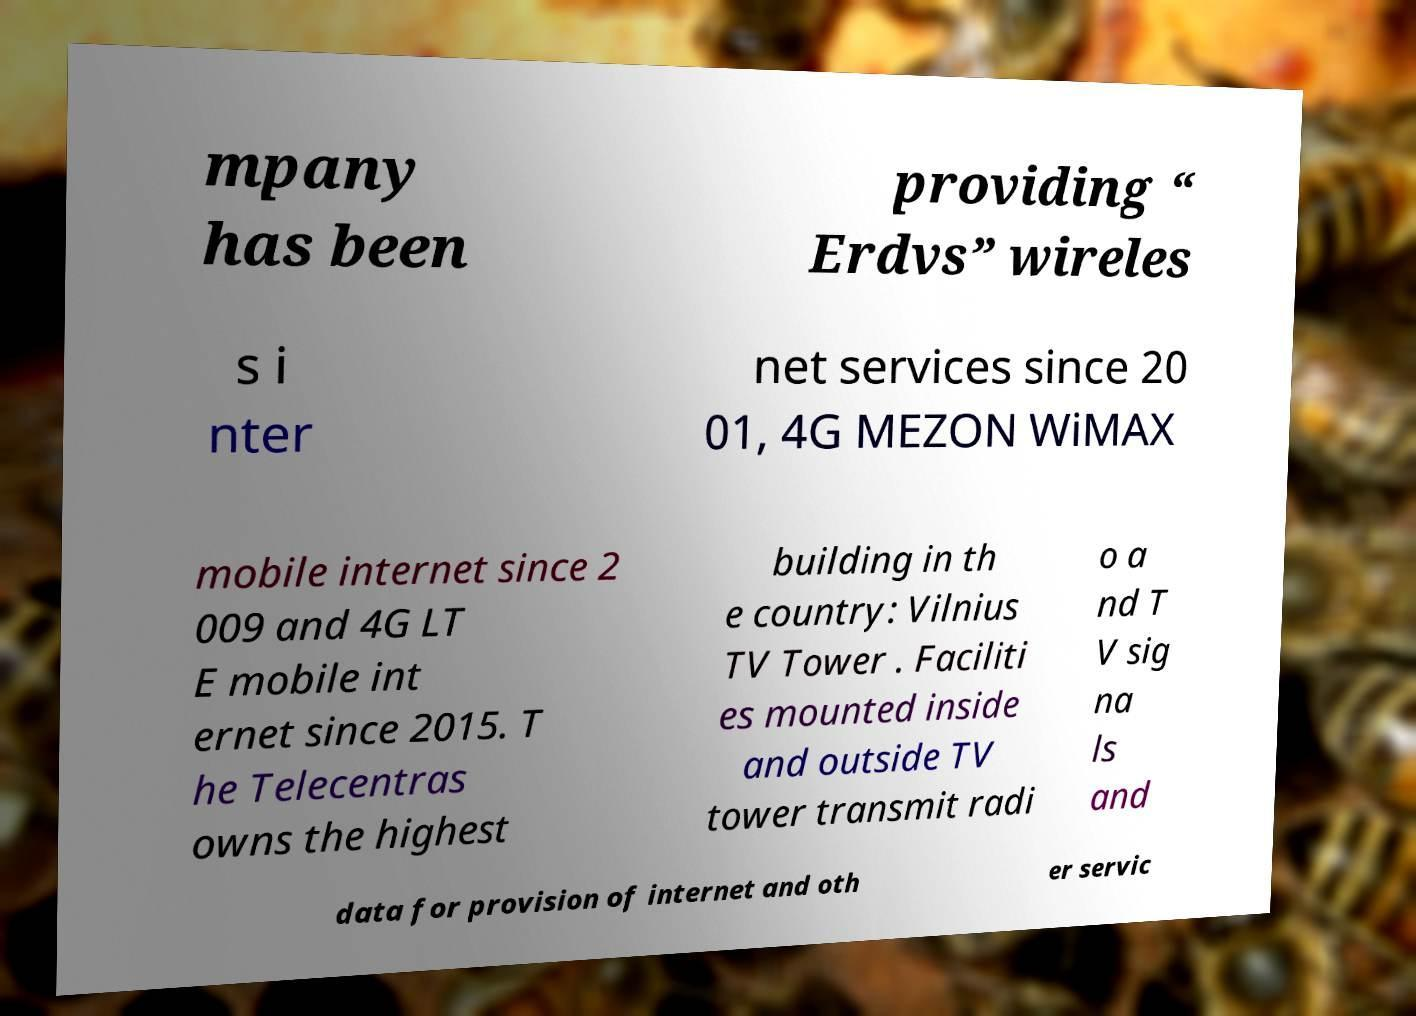Could you extract and type out the text from this image? mpany has been providing “ Erdvs” wireles s i nter net services since 20 01, 4G MEZON WiMAX mobile internet since 2 009 and 4G LT E mobile int ernet since 2015. T he Telecentras owns the highest building in th e country: Vilnius TV Tower . Faciliti es mounted inside and outside TV tower transmit radi o a nd T V sig na ls and data for provision of internet and oth er servic 